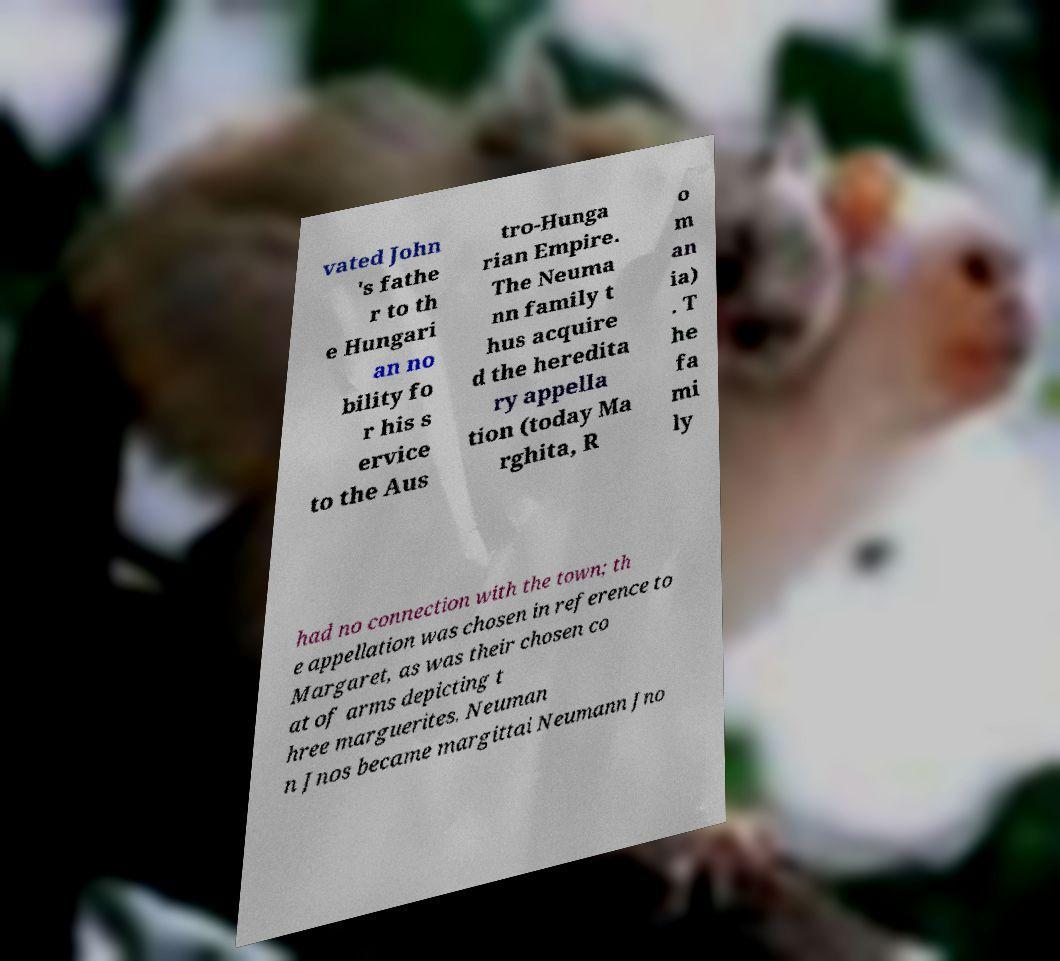Could you assist in decoding the text presented in this image and type it out clearly? vated John 's fathe r to th e Hungari an no bility fo r his s ervice to the Aus tro-Hunga rian Empire. The Neuma nn family t hus acquire d the heredita ry appella tion (today Ma rghita, R o m an ia) . T he fa mi ly had no connection with the town; th e appellation was chosen in reference to Margaret, as was their chosen co at of arms depicting t hree marguerites. Neuman n Jnos became margittai Neumann Jno 